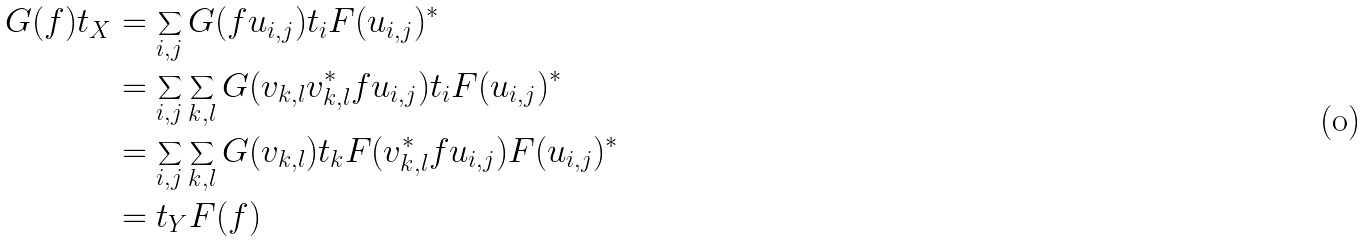Convert formula to latex. <formula><loc_0><loc_0><loc_500><loc_500>G ( f ) t _ { X } & = \sum _ { i , j } G ( f u _ { i , j } ) t _ { i } F ( u _ { i , j } ) ^ { * } \\ & = \sum _ { i , j } \sum _ { k , l } G ( v _ { k , l } v _ { k , l } ^ { * } f u _ { i , j } ) t _ { i } F ( u _ { i , j } ) ^ { * } \\ & = \sum _ { i , j } \sum _ { k , l } G ( v _ { k , l } ) t _ { k } F ( v _ { k , l } ^ { * } f u _ { i , j } ) F ( u _ { i , j } ) ^ { * } \\ & = t _ { Y } F ( f )</formula> 